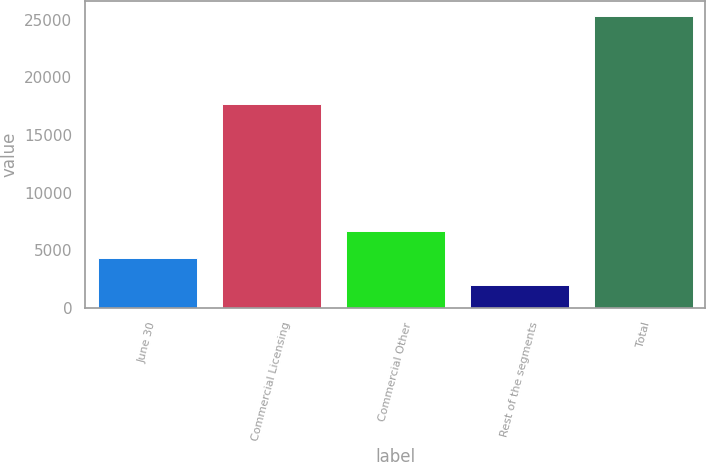<chart> <loc_0><loc_0><loc_500><loc_500><bar_chart><fcel>June 30<fcel>Commercial Licensing<fcel>Commercial Other<fcel>Rest of the segments<fcel>Total<nl><fcel>4336.3<fcel>17672<fcel>6667.6<fcel>2005<fcel>25318<nl></chart> 